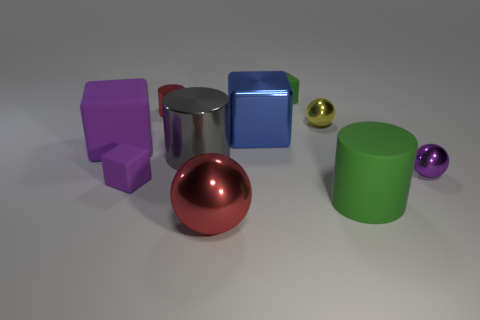Are any objects casting a shadow, and if so, what does this tell us about the light source? All objects in the image are casting shadows to the right, indicating that the light source is coming from the left side, slightly elevated. 